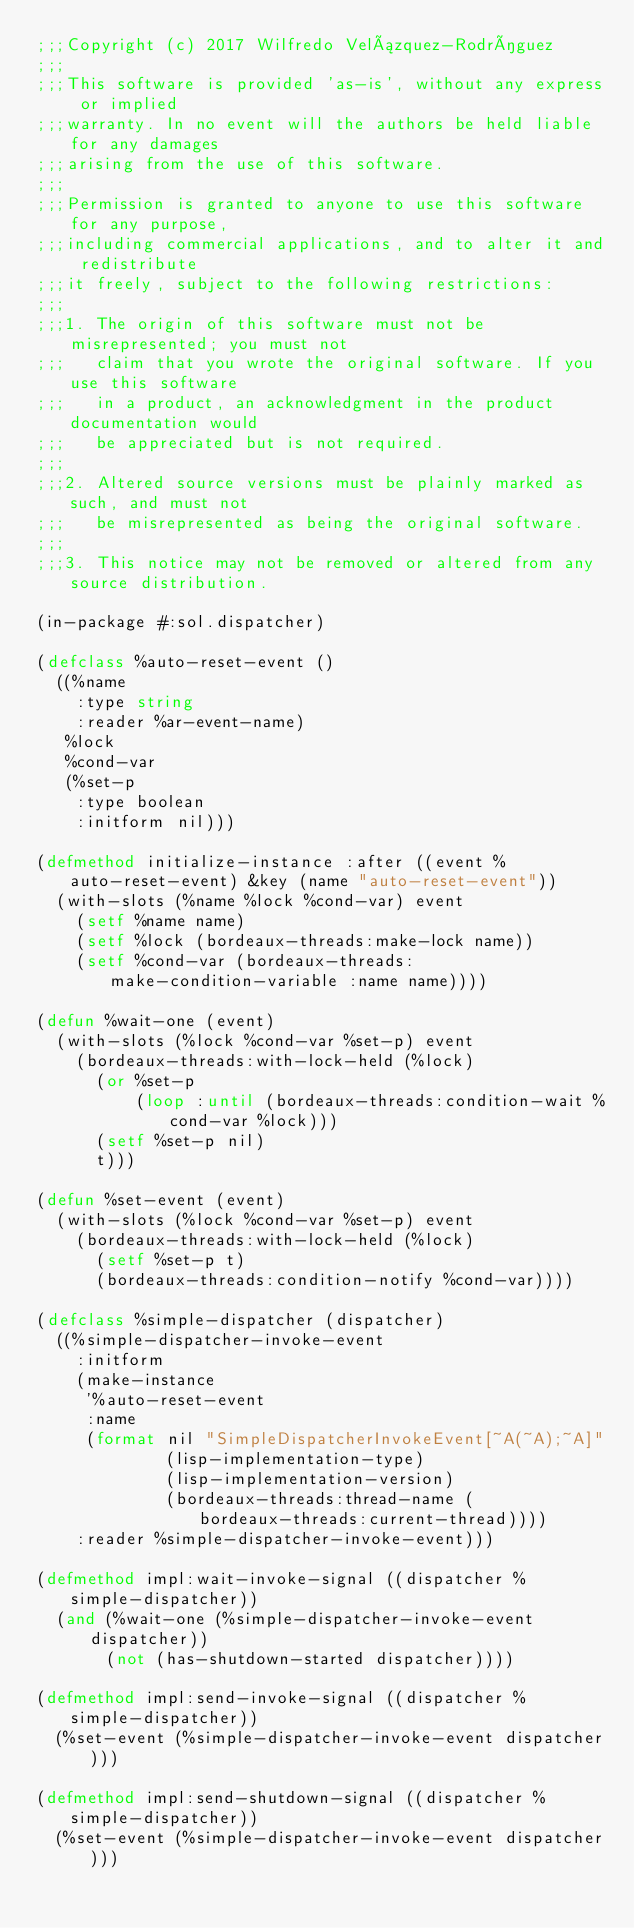<code> <loc_0><loc_0><loc_500><loc_500><_Lisp_>;;;Copyright (c) 2017 Wilfredo Velázquez-Rodríguez
;;;
;;;This software is provided 'as-is', without any express or implied
;;;warranty. In no event will the authors be held liable for any damages
;;;arising from the use of this software.
;;;
;;;Permission is granted to anyone to use this software for any purpose,
;;;including commercial applications, and to alter it and redistribute
;;;it freely, subject to the following restrictions:
;;;
;;;1. The origin of this software must not be misrepresented; you must not
;;;   claim that you wrote the original software. If you use this software
;;;   in a product, an acknowledgment in the product documentation would
;;;   be appreciated but is not required.
;;;
;;;2. Altered source versions must be plainly marked as such, and must not
;;;   be misrepresented as being the original software.
;;;
;;;3. This notice may not be removed or altered from any source distribution.

(in-package #:sol.dispatcher)

(defclass %auto-reset-event ()
  ((%name
    :type string
    :reader %ar-event-name)
   %lock
   %cond-var
   (%set-p
    :type boolean
    :initform nil)))

(defmethod initialize-instance :after ((event %auto-reset-event) &key (name "auto-reset-event"))
  (with-slots (%name %lock %cond-var) event
    (setf %name name)
    (setf %lock (bordeaux-threads:make-lock name))
    (setf %cond-var (bordeaux-threads:make-condition-variable :name name))))

(defun %wait-one (event)
  (with-slots (%lock %cond-var %set-p) event
    (bordeaux-threads:with-lock-held (%lock)
      (or %set-p
          (loop :until (bordeaux-threads:condition-wait %cond-var %lock)))
      (setf %set-p nil)
      t)))

(defun %set-event (event)
  (with-slots (%lock %cond-var %set-p) event
    (bordeaux-threads:with-lock-held (%lock)
      (setf %set-p t)
      (bordeaux-threads:condition-notify %cond-var))))

(defclass %simple-dispatcher (dispatcher)
  ((%simple-dispatcher-invoke-event
    :initform
    (make-instance
     '%auto-reset-event
     :name
     (format nil "SimpleDispatcherInvokeEvent[~A(~A);~A]"
             (lisp-implementation-type)
             (lisp-implementation-version)
             (bordeaux-threads:thread-name (bordeaux-threads:current-thread))))
    :reader %simple-dispatcher-invoke-event)))

(defmethod impl:wait-invoke-signal ((dispatcher %simple-dispatcher))
  (and (%wait-one (%simple-dispatcher-invoke-event dispatcher))
       (not (has-shutdown-started dispatcher))))

(defmethod impl:send-invoke-signal ((dispatcher %simple-dispatcher))
  (%set-event (%simple-dispatcher-invoke-event dispatcher)))

(defmethod impl:send-shutdown-signal ((dispatcher %simple-dispatcher))
  (%set-event (%simple-dispatcher-invoke-event dispatcher)))
</code> 